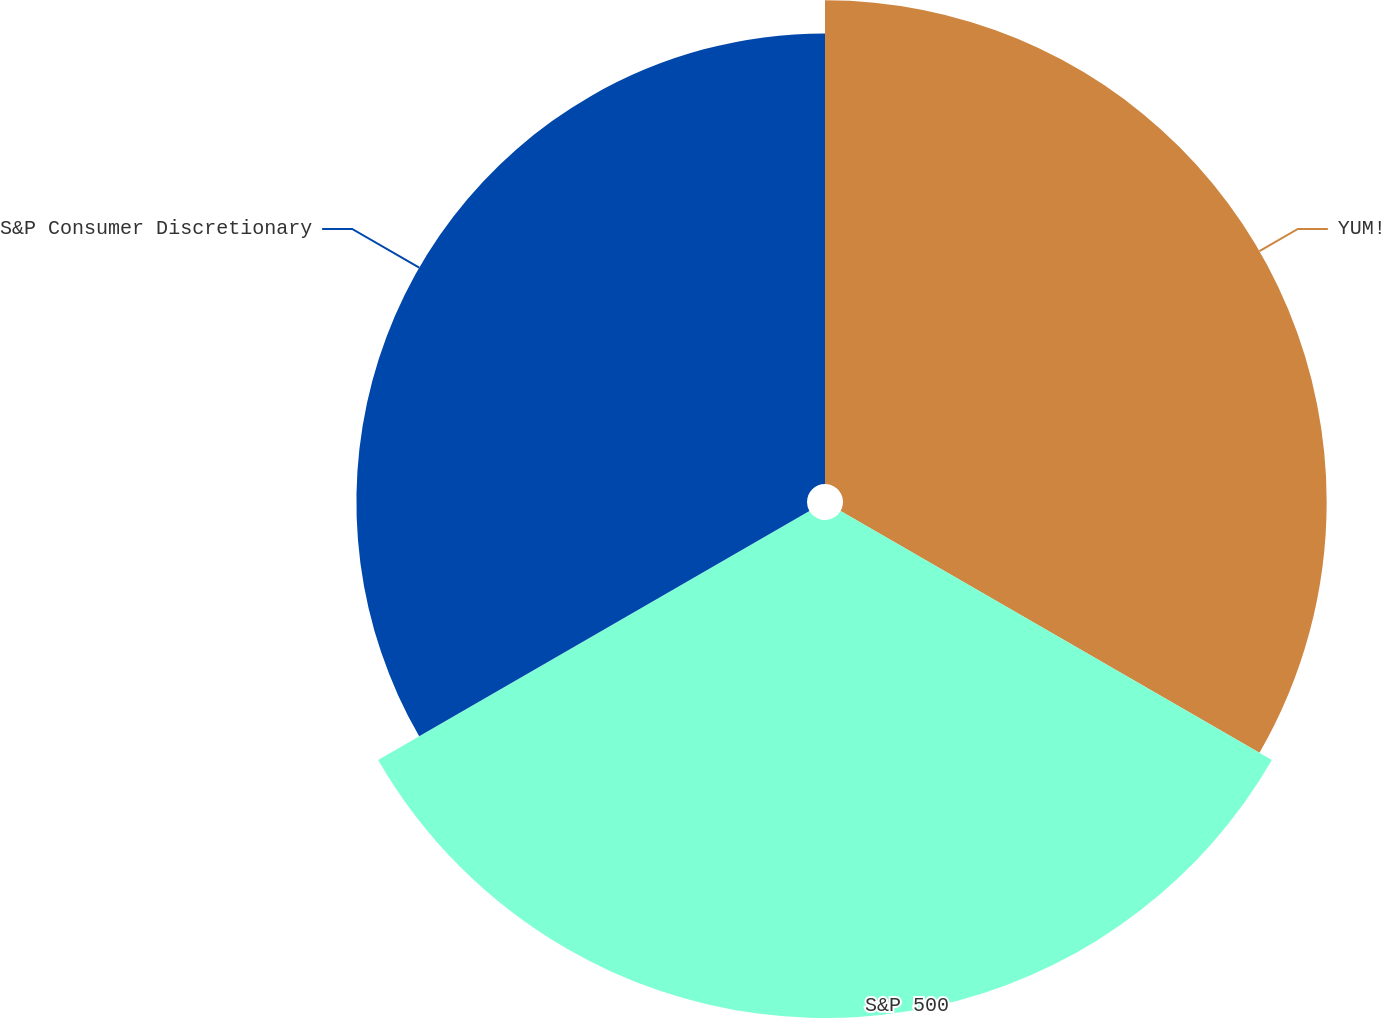<chart> <loc_0><loc_0><loc_500><loc_500><pie_chart><fcel>YUM!<fcel>S&P 500<fcel>S&P Consumer Discretionary<nl><fcel>33.77%<fcel>34.77%<fcel>31.46%<nl></chart> 